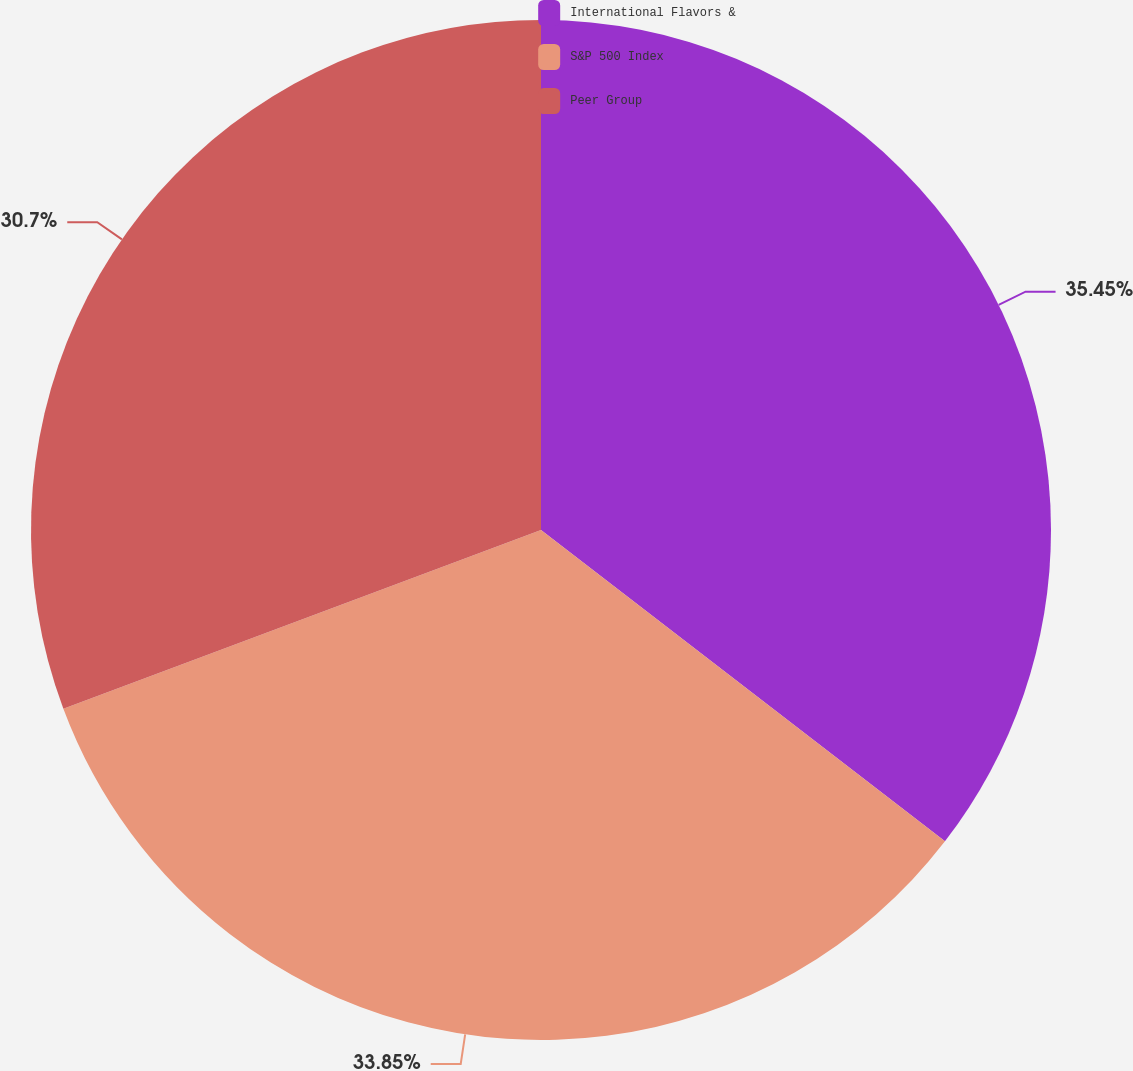Convert chart. <chart><loc_0><loc_0><loc_500><loc_500><pie_chart><fcel>International Flavors &<fcel>S&P 500 Index<fcel>Peer Group<nl><fcel>35.45%<fcel>33.85%<fcel>30.7%<nl></chart> 